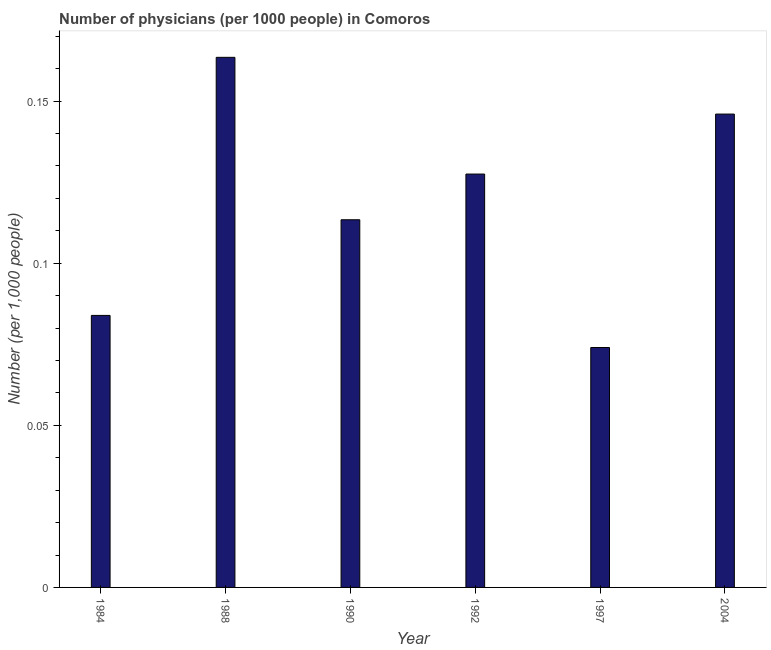Does the graph contain any zero values?
Your answer should be very brief. No. What is the title of the graph?
Give a very brief answer. Number of physicians (per 1000 people) in Comoros. What is the label or title of the X-axis?
Your response must be concise. Year. What is the label or title of the Y-axis?
Make the answer very short. Number (per 1,0 people). What is the number of physicians in 1988?
Offer a terse response. 0.16. Across all years, what is the maximum number of physicians?
Provide a succinct answer. 0.16. Across all years, what is the minimum number of physicians?
Ensure brevity in your answer.  0.07. In which year was the number of physicians minimum?
Your answer should be compact. 1997. What is the sum of the number of physicians?
Give a very brief answer. 0.71. What is the difference between the number of physicians in 1988 and 2004?
Provide a succinct answer. 0.02. What is the average number of physicians per year?
Your response must be concise. 0.12. What is the median number of physicians?
Provide a short and direct response. 0.12. In how many years, is the number of physicians greater than 0.02 ?
Your answer should be very brief. 6. What is the ratio of the number of physicians in 1988 to that in 2004?
Offer a terse response. 1.12. Is the number of physicians in 1992 less than that in 1997?
Give a very brief answer. No. What is the difference between the highest and the second highest number of physicians?
Keep it short and to the point. 0.02. Is the sum of the number of physicians in 1988 and 2004 greater than the maximum number of physicians across all years?
Keep it short and to the point. Yes. What is the difference between the highest and the lowest number of physicians?
Your response must be concise. 0.09. How many bars are there?
Your answer should be very brief. 6. Are all the bars in the graph horizontal?
Your answer should be very brief. No. Are the values on the major ticks of Y-axis written in scientific E-notation?
Offer a terse response. No. What is the Number (per 1,000 people) of 1984?
Give a very brief answer. 0.08. What is the Number (per 1,000 people) of 1988?
Make the answer very short. 0.16. What is the Number (per 1,000 people) in 1990?
Offer a very short reply. 0.11. What is the Number (per 1,000 people) in 1992?
Your answer should be compact. 0.13. What is the Number (per 1,000 people) in 1997?
Provide a succinct answer. 0.07. What is the Number (per 1,000 people) of 2004?
Your response must be concise. 0.15. What is the difference between the Number (per 1,000 people) in 1984 and 1988?
Offer a very short reply. -0.08. What is the difference between the Number (per 1,000 people) in 1984 and 1990?
Your answer should be very brief. -0.03. What is the difference between the Number (per 1,000 people) in 1984 and 1992?
Your answer should be very brief. -0.04. What is the difference between the Number (per 1,000 people) in 1984 and 1997?
Give a very brief answer. 0.01. What is the difference between the Number (per 1,000 people) in 1984 and 2004?
Offer a terse response. -0.06. What is the difference between the Number (per 1,000 people) in 1988 and 1990?
Keep it short and to the point. 0.05. What is the difference between the Number (per 1,000 people) in 1988 and 1992?
Your answer should be very brief. 0.04. What is the difference between the Number (per 1,000 people) in 1988 and 1997?
Provide a short and direct response. 0.09. What is the difference between the Number (per 1,000 people) in 1988 and 2004?
Ensure brevity in your answer.  0.02. What is the difference between the Number (per 1,000 people) in 1990 and 1992?
Your response must be concise. -0.01. What is the difference between the Number (per 1,000 people) in 1990 and 1997?
Provide a succinct answer. 0.04. What is the difference between the Number (per 1,000 people) in 1990 and 2004?
Provide a succinct answer. -0.03. What is the difference between the Number (per 1,000 people) in 1992 and 1997?
Give a very brief answer. 0.05. What is the difference between the Number (per 1,000 people) in 1992 and 2004?
Offer a very short reply. -0.02. What is the difference between the Number (per 1,000 people) in 1997 and 2004?
Make the answer very short. -0.07. What is the ratio of the Number (per 1,000 people) in 1984 to that in 1988?
Your answer should be compact. 0.51. What is the ratio of the Number (per 1,000 people) in 1984 to that in 1990?
Give a very brief answer. 0.74. What is the ratio of the Number (per 1,000 people) in 1984 to that in 1992?
Offer a very short reply. 0.66. What is the ratio of the Number (per 1,000 people) in 1984 to that in 1997?
Your answer should be very brief. 1.13. What is the ratio of the Number (per 1,000 people) in 1984 to that in 2004?
Ensure brevity in your answer.  0.57. What is the ratio of the Number (per 1,000 people) in 1988 to that in 1990?
Provide a short and direct response. 1.44. What is the ratio of the Number (per 1,000 people) in 1988 to that in 1992?
Your answer should be compact. 1.28. What is the ratio of the Number (per 1,000 people) in 1988 to that in 1997?
Keep it short and to the point. 2.21. What is the ratio of the Number (per 1,000 people) in 1988 to that in 2004?
Offer a very short reply. 1.12. What is the ratio of the Number (per 1,000 people) in 1990 to that in 1992?
Provide a short and direct response. 0.89. What is the ratio of the Number (per 1,000 people) in 1990 to that in 1997?
Keep it short and to the point. 1.53. What is the ratio of the Number (per 1,000 people) in 1990 to that in 2004?
Keep it short and to the point. 0.78. What is the ratio of the Number (per 1,000 people) in 1992 to that in 1997?
Give a very brief answer. 1.72. What is the ratio of the Number (per 1,000 people) in 1992 to that in 2004?
Offer a terse response. 0.87. What is the ratio of the Number (per 1,000 people) in 1997 to that in 2004?
Your answer should be compact. 0.51. 